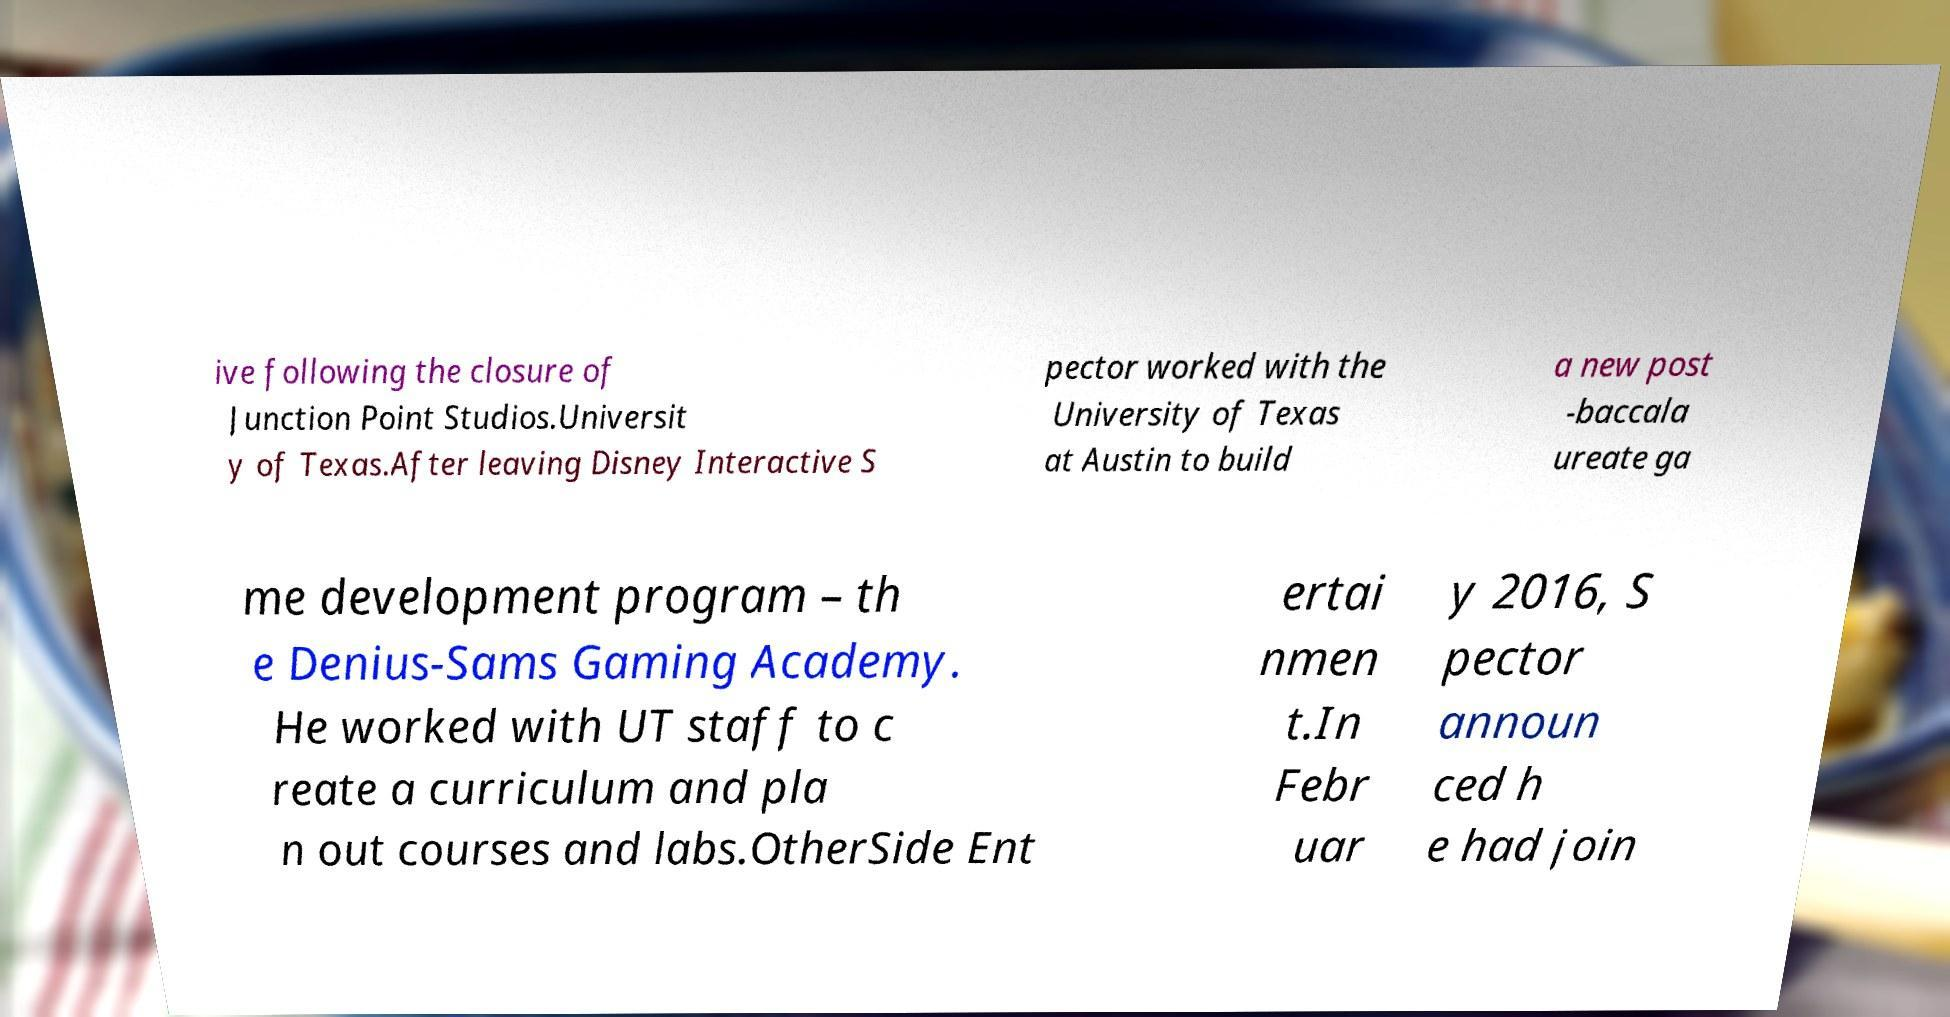For documentation purposes, I need the text within this image transcribed. Could you provide that? ive following the closure of Junction Point Studios.Universit y of Texas.After leaving Disney Interactive S pector worked with the University of Texas at Austin to build a new post -baccala ureate ga me development program – th e Denius-Sams Gaming Academy. He worked with UT staff to c reate a curriculum and pla n out courses and labs.OtherSide Ent ertai nmen t.In Febr uar y 2016, S pector announ ced h e had join 